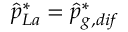Convert formula to latex. <formula><loc_0><loc_0><loc_500><loc_500>\hat { p } _ { L a } ^ { * } = \hat { p } _ { g , d i f } ^ { * }</formula> 